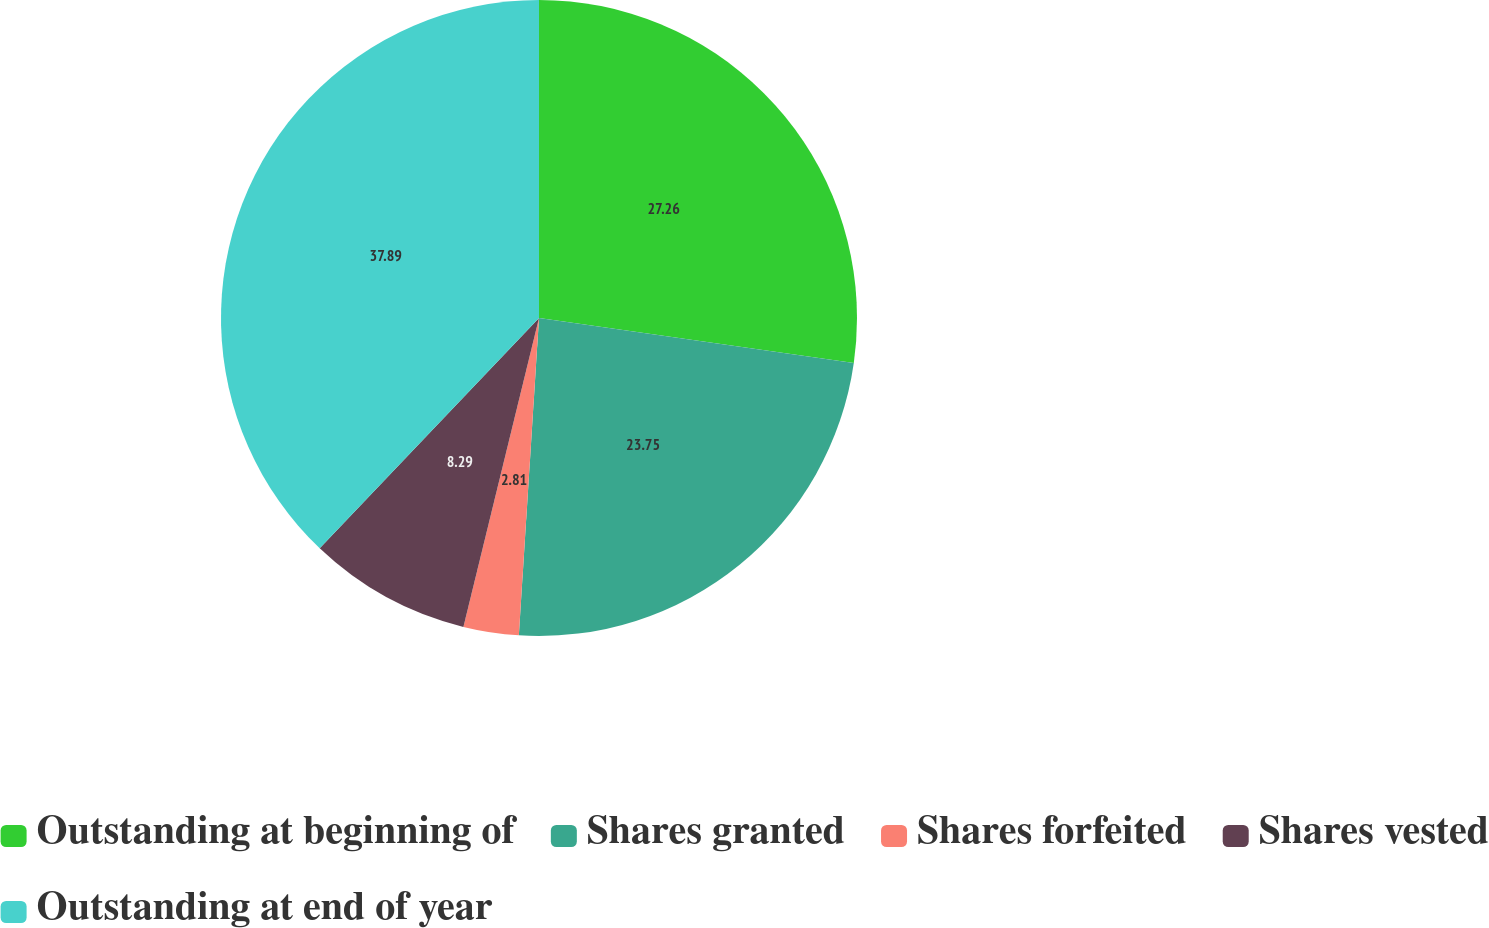Convert chart. <chart><loc_0><loc_0><loc_500><loc_500><pie_chart><fcel>Outstanding at beginning of<fcel>Shares granted<fcel>Shares forfeited<fcel>Shares vested<fcel>Outstanding at end of year<nl><fcel>27.26%<fcel>23.75%<fcel>2.81%<fcel>8.29%<fcel>37.89%<nl></chart> 